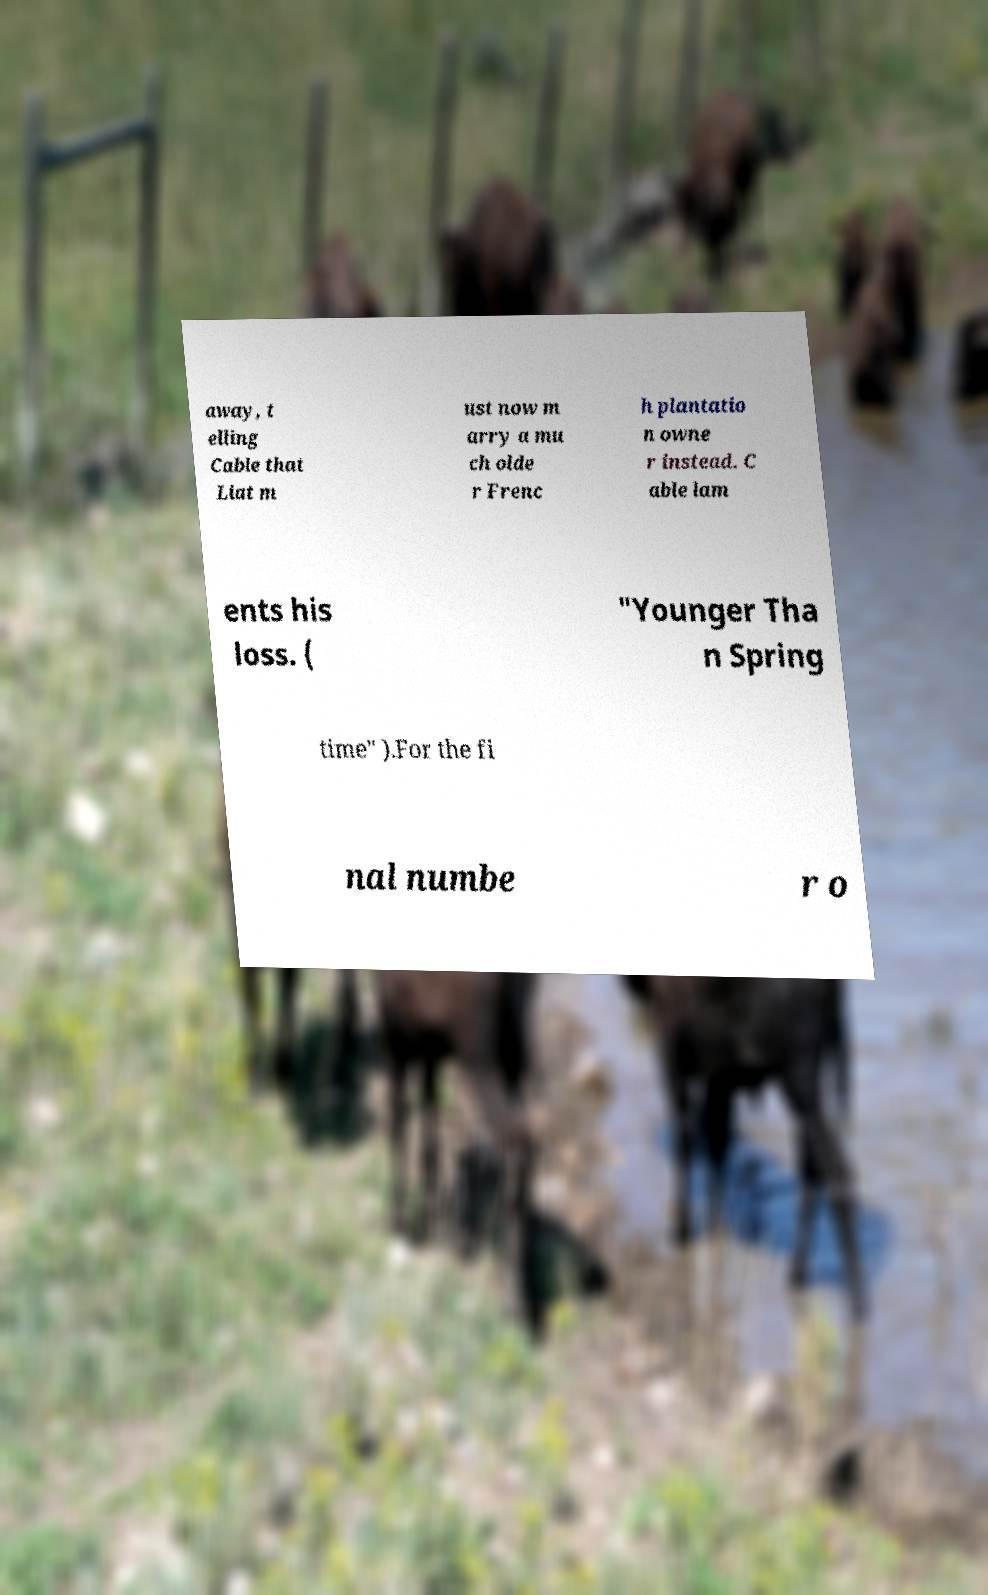I need the written content from this picture converted into text. Can you do that? away, t elling Cable that Liat m ust now m arry a mu ch olde r Frenc h plantatio n owne r instead. C able lam ents his loss. ( "Younger Tha n Spring time" ).For the fi nal numbe r o 